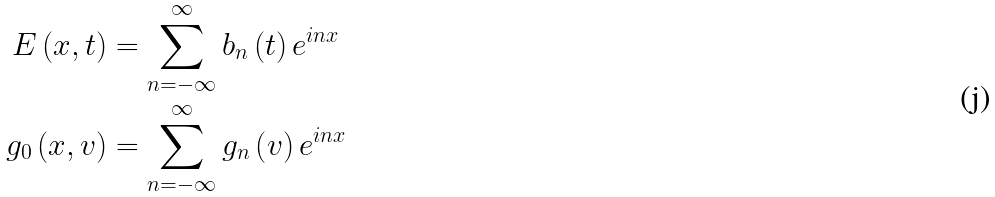Convert formula to latex. <formula><loc_0><loc_0><loc_500><loc_500>E \left ( x , t \right ) & = \sum _ { n = - \infty } ^ { \infty } b _ { n } \left ( t \right ) e ^ { i n x } \\ g _ { 0 } \left ( x , v \right ) & = \sum _ { n = - \infty } ^ { \infty } g _ { n } \left ( v \right ) e ^ { i n x }</formula> 